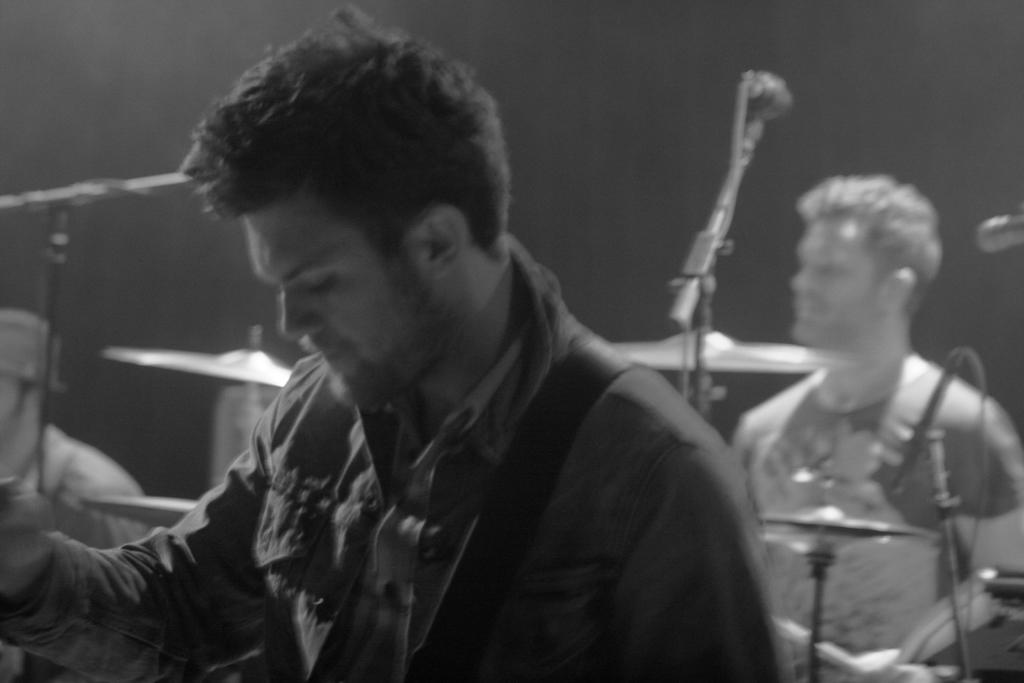How many people are in the image? There are 3 persons in the image. What are the persons doing in the image? The persons are near musical instruments. Can you describe any other objects in the image besides the musical instruments? There are 2 tripods in the image. What is the color scheme of the image? The image is black and white. How would you describe the lighting in the image? The background is dark. What type of cap can be seen on the person playing the guitar in the image? There is no cap visible on any person in the image, as it is a black and white image with a dark background. How many pies are on the table next to the musical instruments in the image? There are no pies present in the image; it only features musical instruments, tripods, and people. 